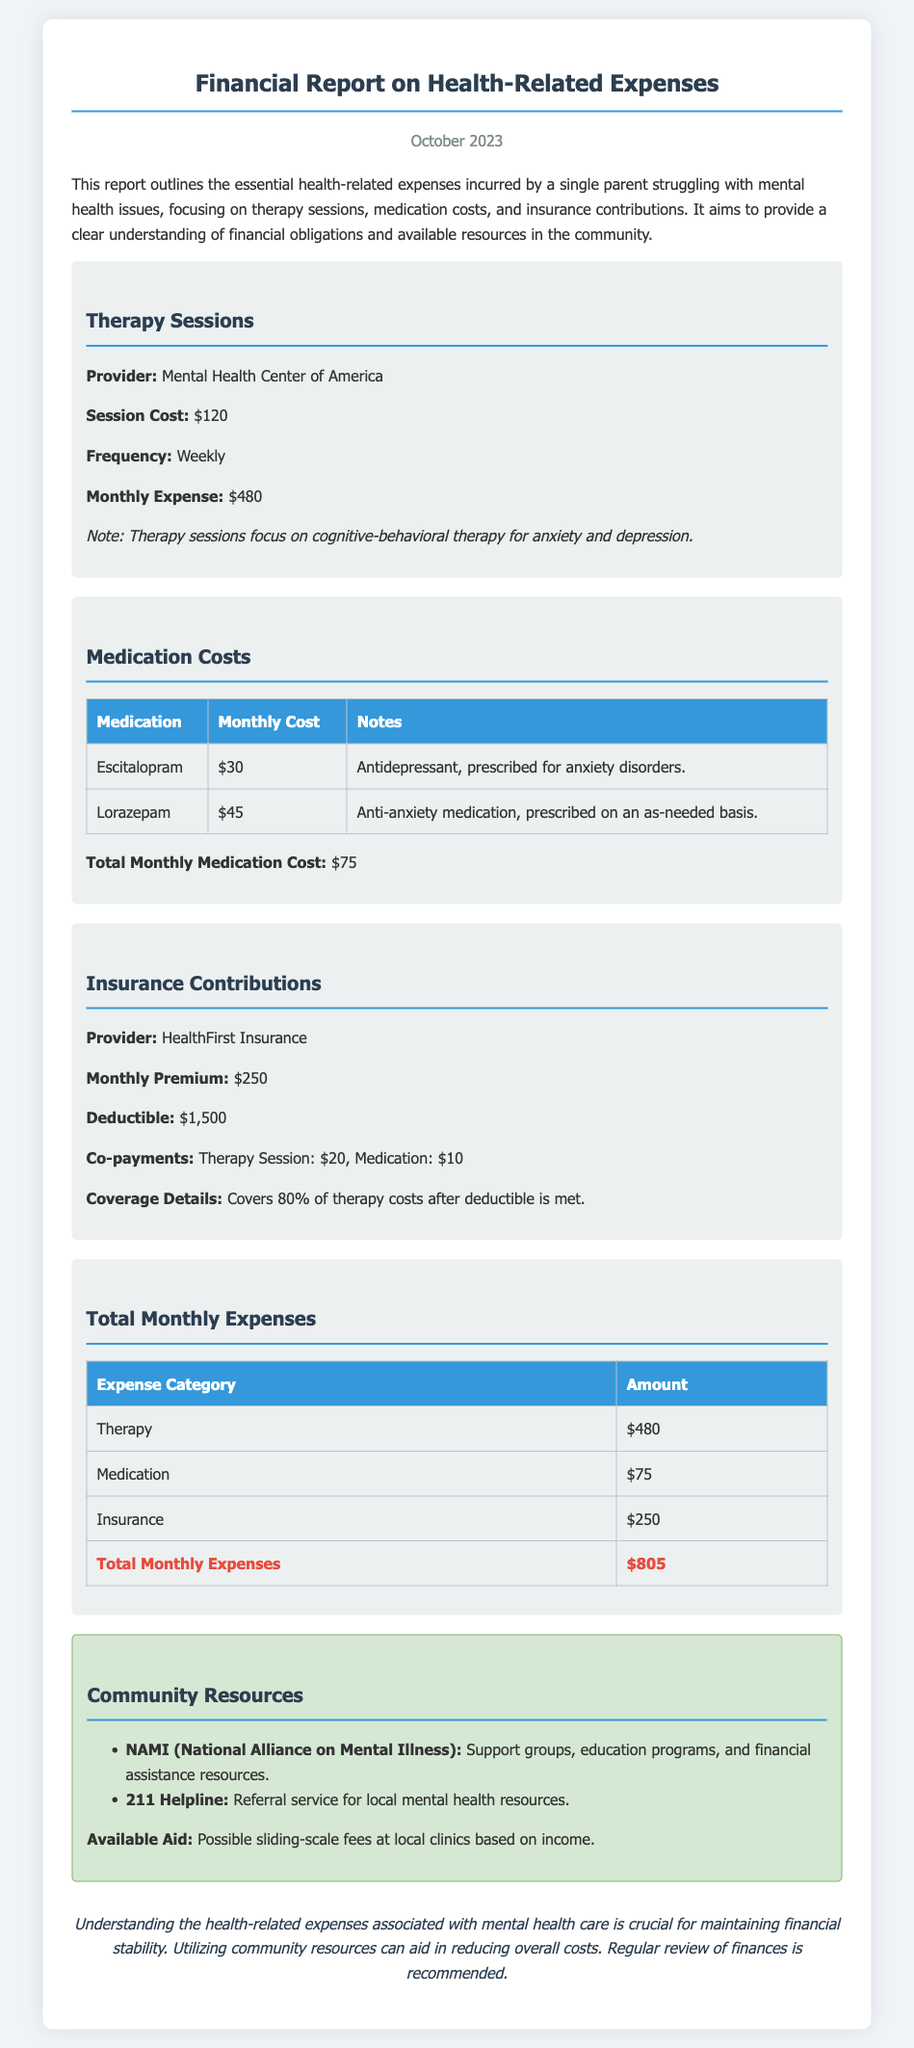What is the session cost for therapy? The document states that the session cost for therapy is $120.
Answer: $120 What is the monthly expense for therapy sessions? The report indicates that the monthly expense for therapy sessions is $480.
Answer: $480 What is the total monthly medication cost? The document summarizes the total monthly medication cost as $75.
Answer: $75 What is the monthly premium for insurance? The monthly premium for insurance is provided as $250 in the report.
Answer: $250 How frequently are therapy sessions held? According to the report, therapy sessions are held weekly.
Answer: Weekly What percentage of therapy costs does the insurance cover after the deductible? The insurance covers 80% of therapy costs after the deductible is met.
Answer: 80% How much are the co-payments for therapy sessions? The document specifies the co-payment for therapy sessions as $20.
Answer: $20 What is the total amount of monthly expenses? The report concludes that the total monthly expenses amount to $805.
Answer: $805 What community resource offers support groups and education programs? The document lists NAMI (National Alliance on Mental Illness) as a community resource offering support groups and education.
Answer: NAMI (National Alliance on Mental Illness) 